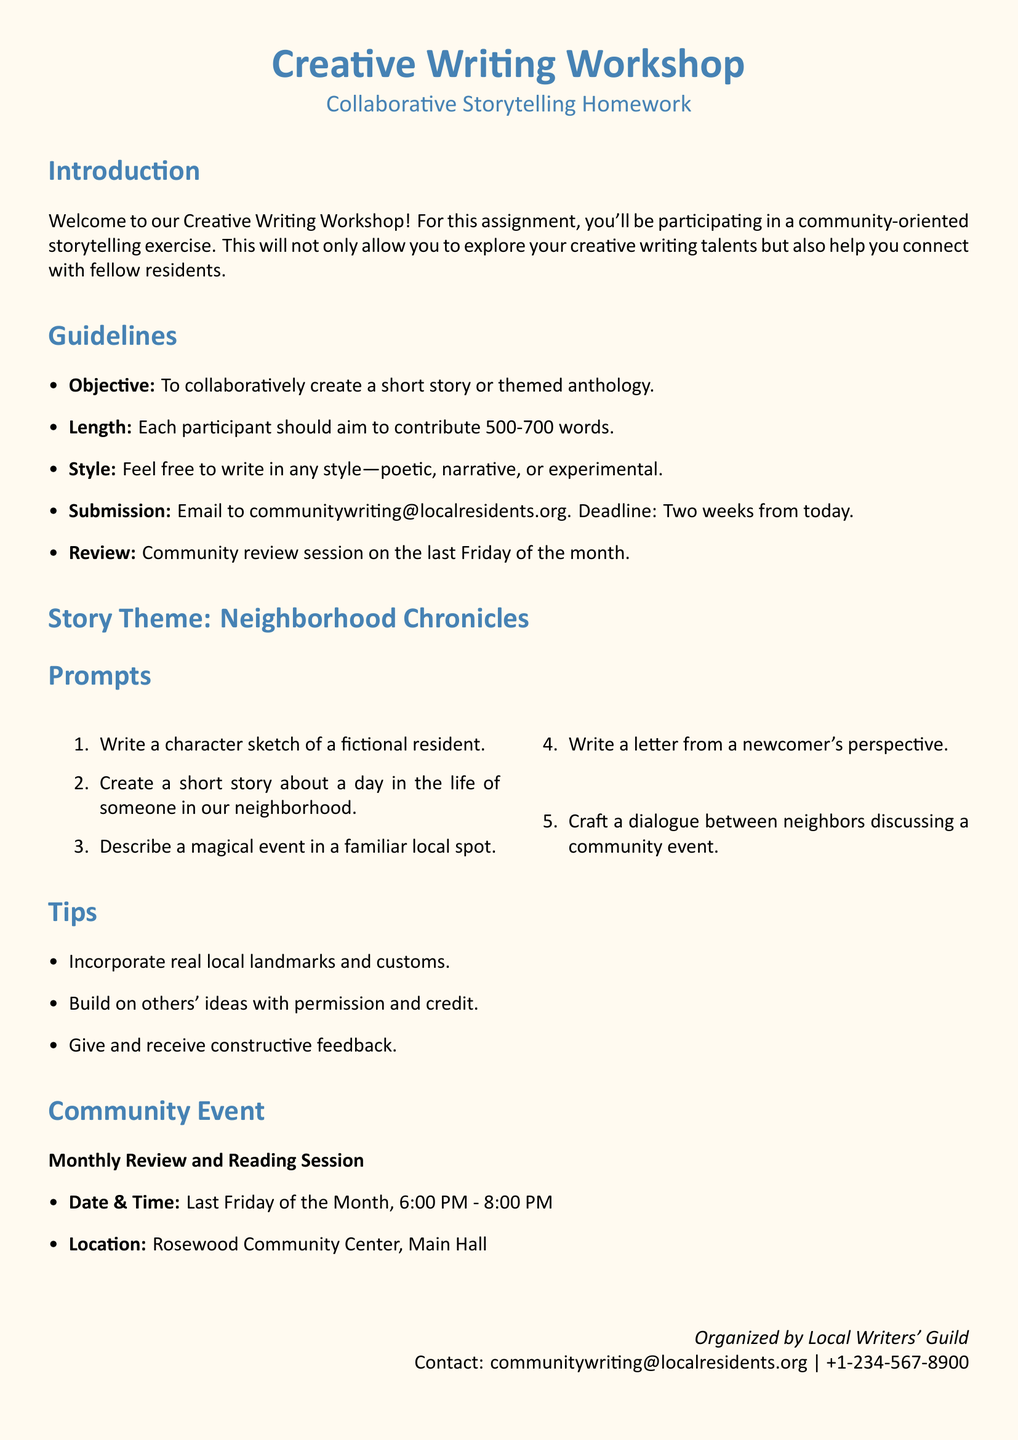What is the objective of the assignment? The objective of the assignment is stated clearly in the guidelines, which is to collaboratively create a short story or themed anthology.
Answer: To collaboratively create a short story or themed anthology What is the maximum word count for each contribution? The maximum word count is specified in the guidelines for participant contributions, which is 700 words.
Answer: 700 words When is the community review session scheduled? The document specifies the community review session will take place on the last Friday of the month.
Answer: Last Friday of the month What is one of the story prompts provided? The document lists several prompts, and one example is a character sketch of a fictional resident.
Answer: Character sketch of a fictional resident Where will the monthly review and reading session be held? The location for the event is mentioned in the document as the Rosewood Community Center, Main Hall.
Answer: Rosewood Community Center, Main Hall How long do participants have to submit their stories? The timeline for submission is specified in the guidelines, stating the deadline is two weeks from today.
Answer: Two weeks from today What is the contact email for inquiries? The document provides a specific contact email for the organizers of the workshop.
Answer: communitywriting@localresidents.org What time does the monthly review session start? The time for the session is specified in the document, stating it begins at 6:00 PM.
Answer: 6:00 PM 